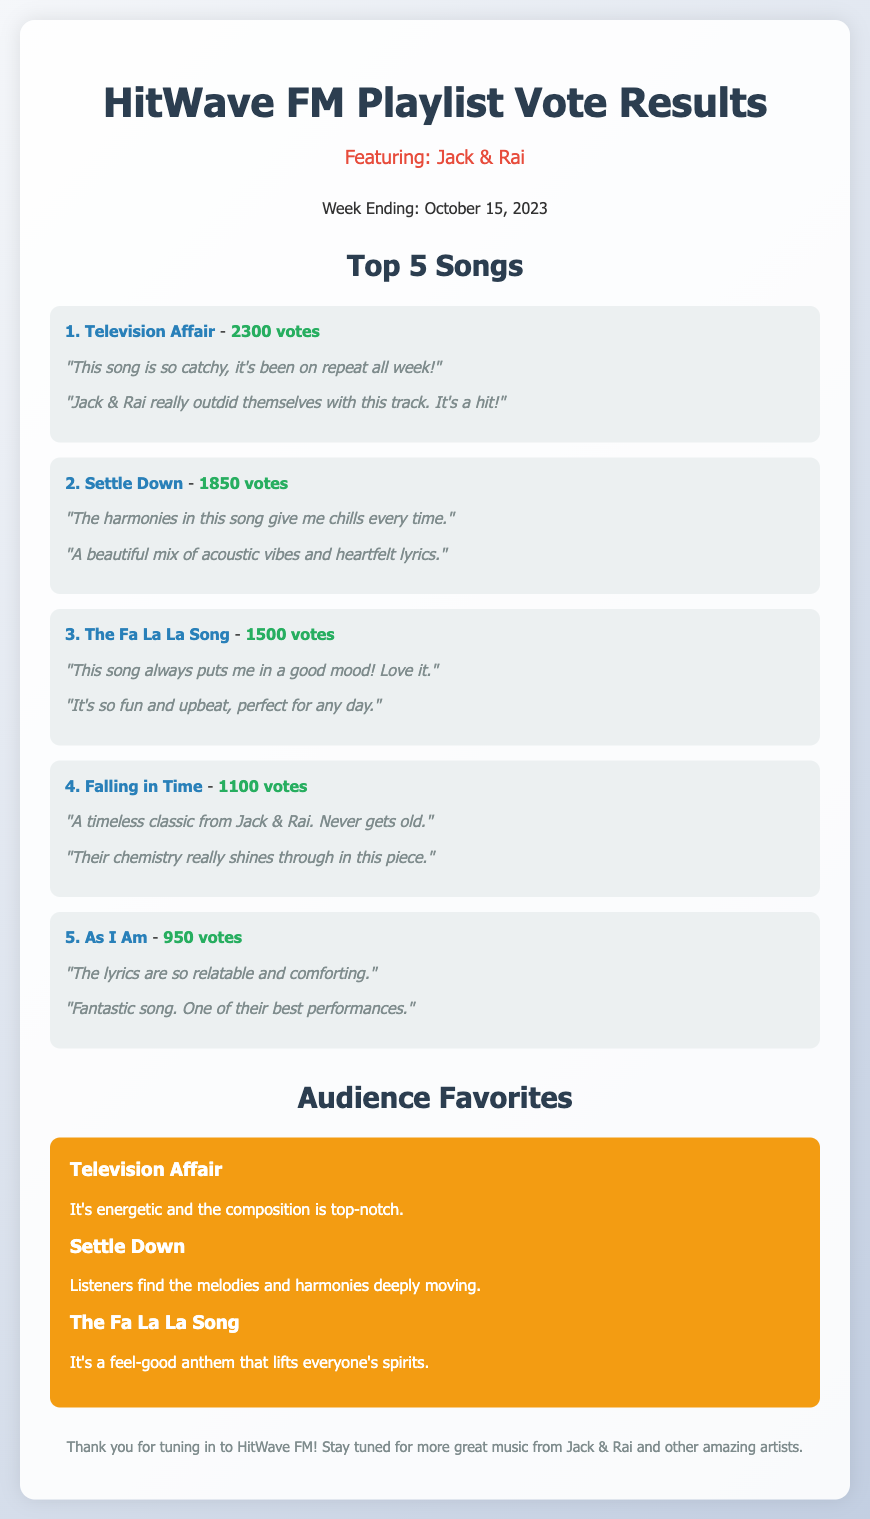What is the title of the song with the highest votes? The song with the highest votes is listed first in the top 5 songs section.
Answer: Television Affair How many votes did "Settle Down" receive? The number of votes for "Settle Down" is shown next to its title in the vote results section.
Answer: 1850 votes Which song is described as a feel-good anthem? The feel-good anthem is specifically mentioned in the audience favorites section.
Answer: The Fa La La Song What is the total number of votes for the top 5 songs listed? The total votes can be calculated by adding all the votes from the top 5 songs.
Answer: 10000 votes Which song appeared in both the top 5 songs and audience favorites? The song appears in both sections, indicating it's popular among listeners.
Answer: Television Affair What are the comments associated with "Falling in Time"? The comments about "Falling in Time" can be found in the vote results section under its title.
Answer: "A timeless classic from Jack & Rai. Never gets old." and "Their chemistry really shines through in this piece." What is the main theme of audience favorites? The audience favorites section consists of songs that listeners particularly enjoy or connect with.
Answer: Energetic and moving melodies 